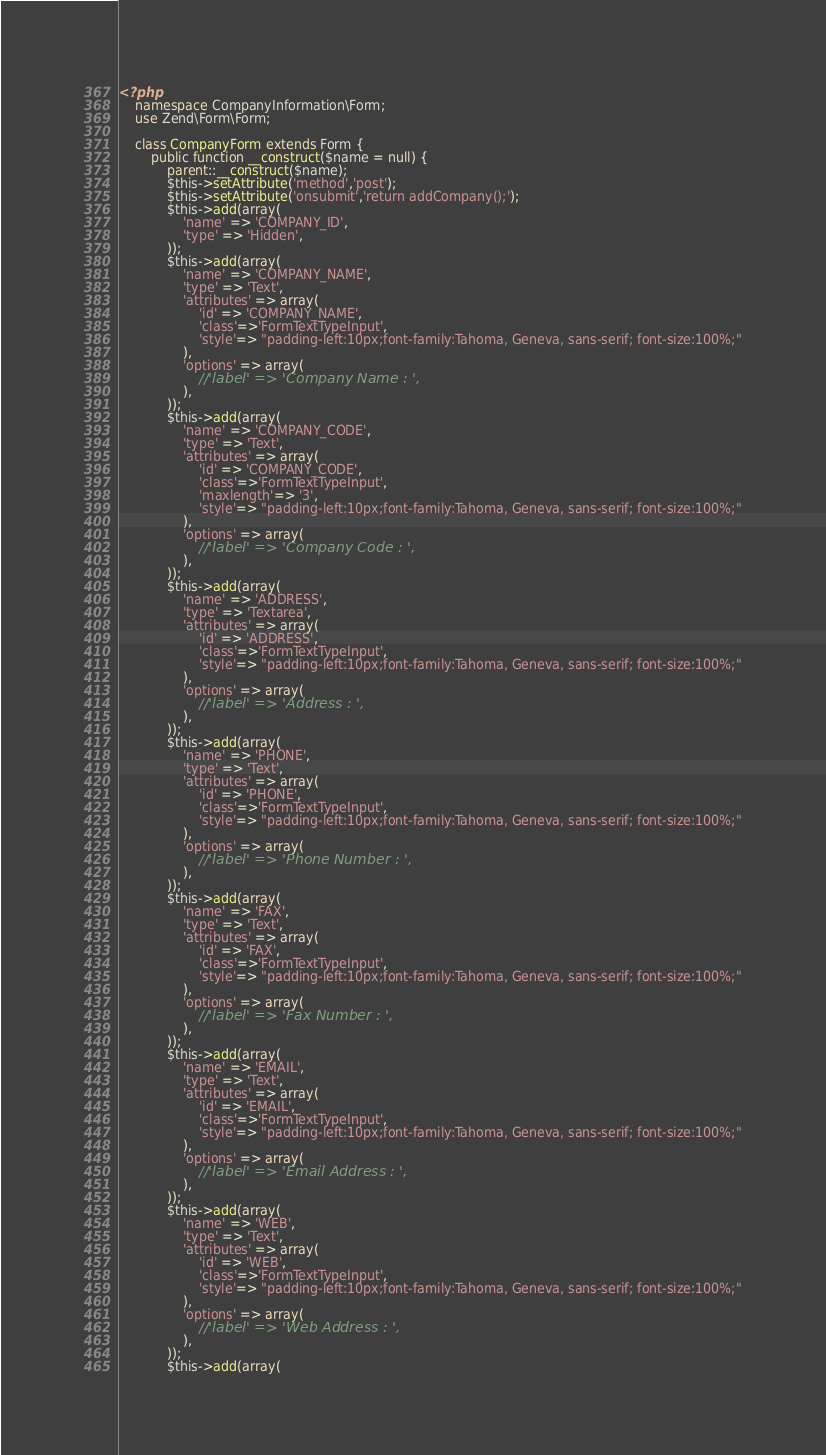<code> <loc_0><loc_0><loc_500><loc_500><_PHP_><?php
	namespace CompanyInformation\Form;
	use Zend\Form\Form;
	
	class CompanyForm extends Form {
		public function __construct($name = null) {
			parent::__construct($name);
			$this->setAttribute('method','post');
			$this->setAttribute('onsubmit','return addCompany();');
			$this->add(array(
				'name' => 'COMPANY_ID',
				'type' => 'Hidden',
			));
			$this->add(array(
				'name' => 'COMPANY_NAME',
				'type' => 'Text',
				'attributes' => array(
					'id' => 'COMPANY_NAME',
					'class'=>'FormTextTypeInput',
					'style'=> "padding-left:10px;font-family:Tahoma, Geneva, sans-serif; font-size:100%;"
				),
				'options' => array(
					//'label' => 'Company Name : ',
				),
			));
			$this->add(array(
				'name' => 'COMPANY_CODE',
				'type' => 'Text',
				'attributes' => array(
					'id' => 'COMPANY_CODE',
					'class'=>'FormTextTypeInput',
					'maxlength'=> '3',
					'style'=> "padding-left:10px;font-family:Tahoma, Geneva, sans-serif; font-size:100%;"
				),
				'options' => array(
					//'label' => 'Company Code : ',
				),
			));
			$this->add(array(
				'name' => 'ADDRESS',
				'type' => 'Textarea',
				'attributes' => array(
					'id' => 'ADDRESS',
					'class'=>'FormTextTypeInput',
					'style'=> "padding-left:10px;font-family:Tahoma, Geneva, sans-serif; font-size:100%;"
				),
				'options' => array(
					//'label' => 'Address : ',
				),
			));
			$this->add(array(
				'name' => 'PHONE',
				'type' => 'Text',
				'attributes' => array(
					'id' => 'PHONE',
					'class'=>'FormTextTypeInput',
					'style'=> "padding-left:10px;font-family:Tahoma, Geneva, sans-serif; font-size:100%;"
				),
				'options' => array(
					//'label' => 'Phone Number : ',
				),
			));
			$this->add(array(
				'name' => 'FAX',
				'type' => 'Text',
				'attributes' => array(
					'id' => 'FAX',
					'class'=>'FormTextTypeInput',
					'style'=> "padding-left:10px;font-family:Tahoma, Geneva, sans-serif; font-size:100%;"
				),
				'options' => array(
					//'label' => 'Fax Number : ',
				),
			));
			$this->add(array(
				'name' => 'EMAIL',
				'type' => 'Text',
				'attributes' => array(
					'id' => 'EMAIL',
					'class'=>'FormTextTypeInput',
					'style'=> "padding-left:10px;font-family:Tahoma, Geneva, sans-serif; font-size:100%;"
				),
				'options' => array(
					//'label' => 'Email Address : ',
				),
			));
			$this->add(array(
				'name' => 'WEB',
				'type' => 'Text',
				'attributes' => array(
					'id' => 'WEB',
					'class'=>'FormTextTypeInput',
					'style'=> "padding-left:10px;font-family:Tahoma, Geneva, sans-serif; font-size:100%;"
				),
				'options' => array(
					//'label' => 'Web Address : ',
				),
			));
			$this->add(array(</code> 